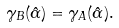Convert formula to latex. <formula><loc_0><loc_0><loc_500><loc_500>\gamma _ { B } ( \hat { \alpha } ) = \gamma _ { A } ( \hat { \alpha } ) .</formula> 